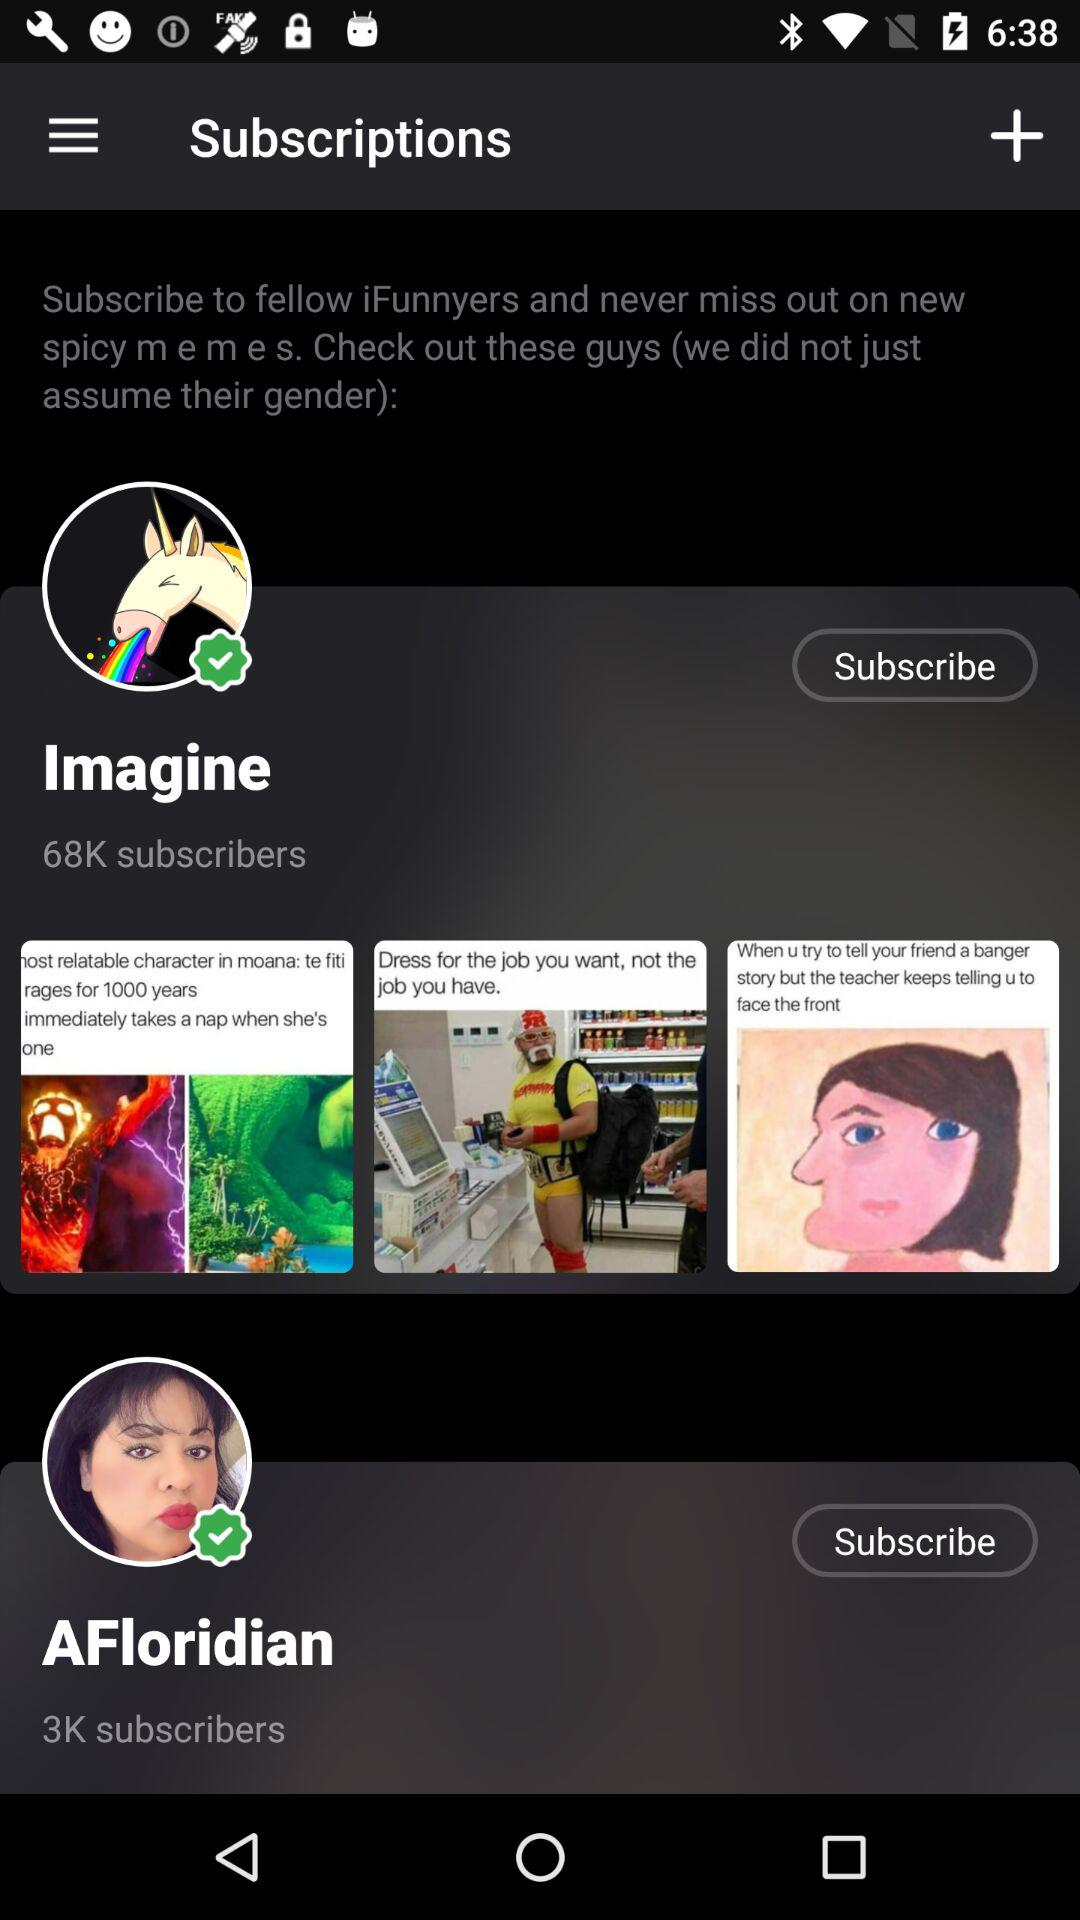How many subscribers are there for "Imagine"? There are 68000 subscribers for "Imagine". 